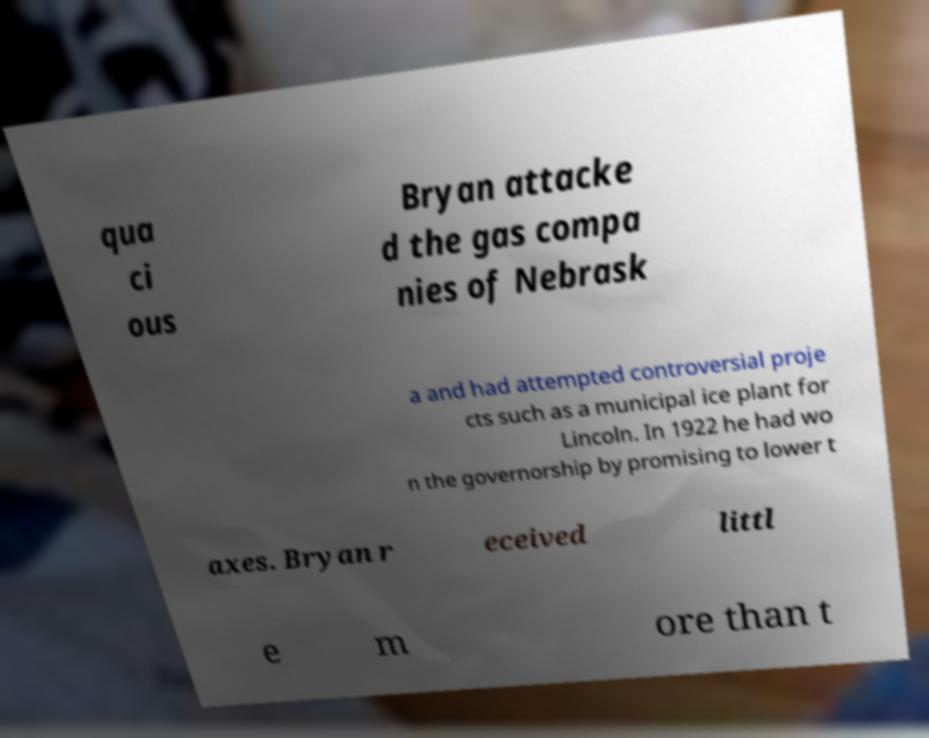Please read and relay the text visible in this image. What does it say? qua ci ous Bryan attacke d the gas compa nies of Nebrask a and had attempted controversial proje cts such as a municipal ice plant for Lincoln. In 1922 he had wo n the governorship by promising to lower t axes. Bryan r eceived littl e m ore than t 